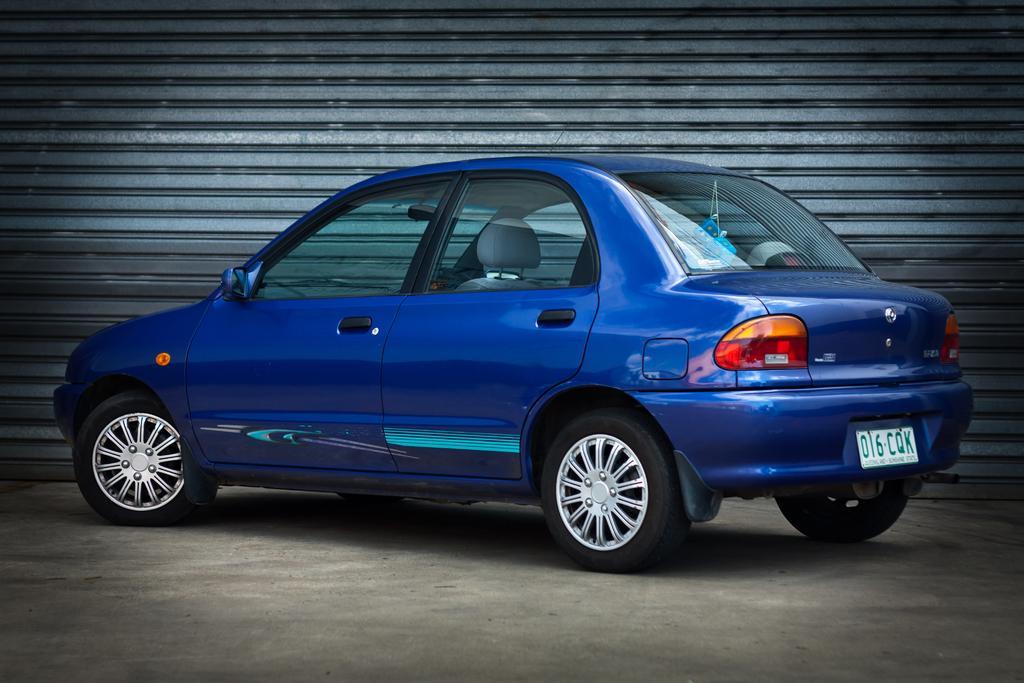Please provide a concise description of this image. In this picture I can see the path in front, on which there is a blue color car and I see a number plate on which there are numbers and alphabets written. In the background I see the shutter. 